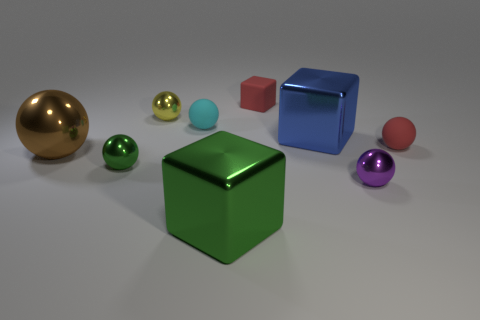Subtract all red blocks. How many blocks are left? 2 Subtract 4 spheres. How many spheres are left? 2 Subtract all blue blocks. How many blocks are left? 2 Subtract all blocks. How many objects are left? 6 Subtract all yellow cylinders. How many brown blocks are left? 0 Subtract all large brown metallic spheres. Subtract all large gray rubber blocks. How many objects are left? 8 Add 1 tiny green shiny objects. How many tiny green shiny objects are left? 2 Add 5 tiny green balls. How many tiny green balls exist? 6 Subtract 0 brown cylinders. How many objects are left? 9 Subtract all red balls. Subtract all red blocks. How many balls are left? 5 